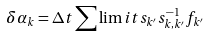<formula> <loc_0><loc_0><loc_500><loc_500>\delta \alpha _ { k } = \Delta t \sum \lim i t s _ { k ^ { \prime } } s ^ { - 1 } _ { k , k ^ { \prime } } f _ { k ^ { \prime } }</formula> 